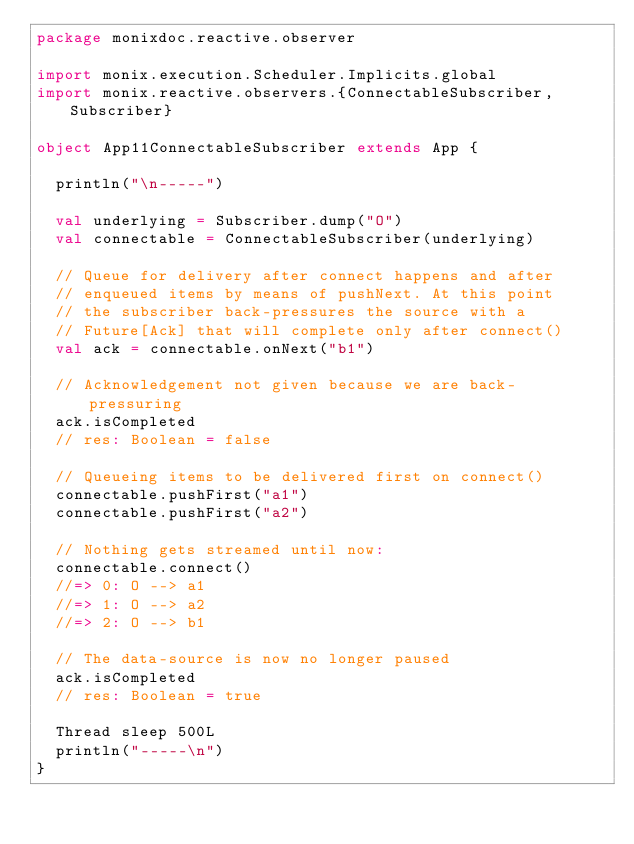Convert code to text. <code><loc_0><loc_0><loc_500><loc_500><_Scala_>package monixdoc.reactive.observer

import monix.execution.Scheduler.Implicits.global
import monix.reactive.observers.{ConnectableSubscriber, Subscriber}

object App11ConnectableSubscriber extends App {

  println("\n-----")

  val underlying = Subscriber.dump("O")
  val connectable = ConnectableSubscriber(underlying)

  // Queue for delivery after connect happens and after
  // enqueued items by means of pushNext. At this point
  // the subscriber back-pressures the source with a
  // Future[Ack] that will complete only after connect()
  val ack = connectable.onNext("b1")

  // Acknowledgement not given because we are back-pressuring
  ack.isCompleted
  // res: Boolean = false

  // Queueing items to be delivered first on connect()
  connectable.pushFirst("a1")
  connectable.pushFirst("a2")

  // Nothing gets streamed until now:
  connectable.connect()
  //=> 0: O --> a1
  //=> 1: O --> a2
  //=> 2: O --> b1

  // The data-source is now no longer paused
  ack.isCompleted
  // res: Boolean = true

  Thread sleep 500L
  println("-----\n")
}
</code> 